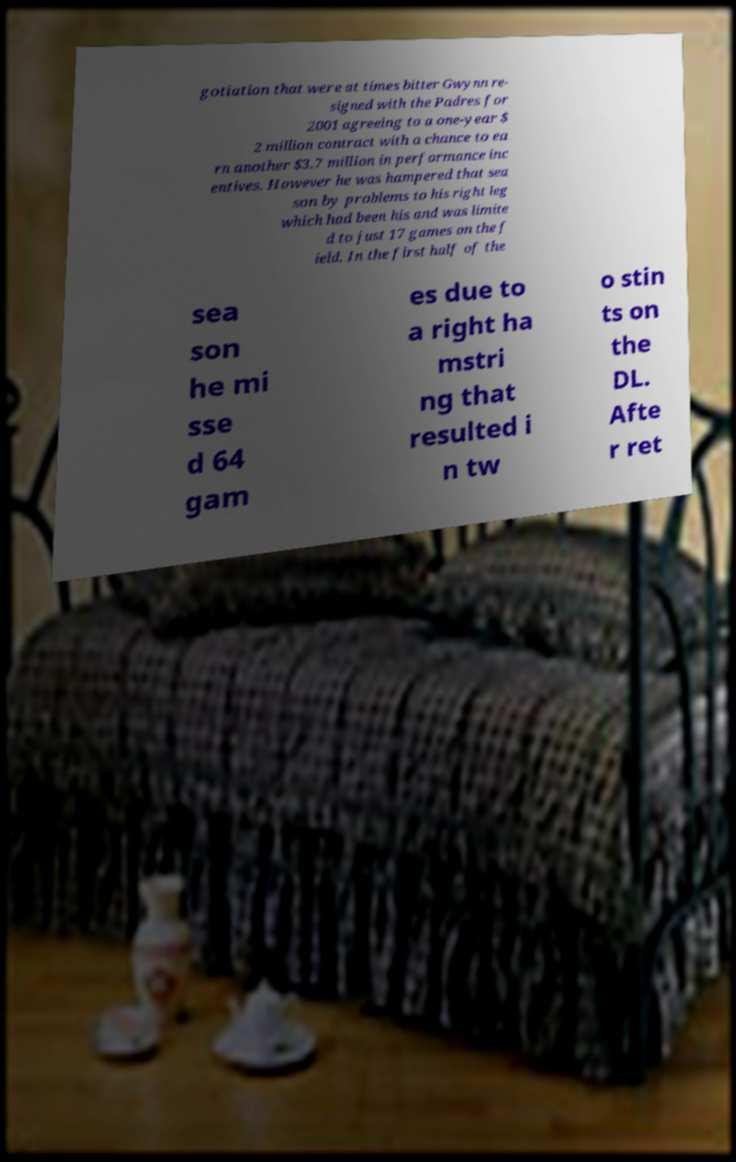Please read and relay the text visible in this image. What does it say? gotiation that were at times bitter Gwynn re- signed with the Padres for 2001 agreeing to a one-year $ 2 million contract with a chance to ea rn another $3.7 million in performance inc entives. However he was hampered that sea son by problems to his right leg which had been his and was limite d to just 17 games on the f ield. In the first half of the sea son he mi sse d 64 gam es due to a right ha mstri ng that resulted i n tw o stin ts on the DL. Afte r ret 